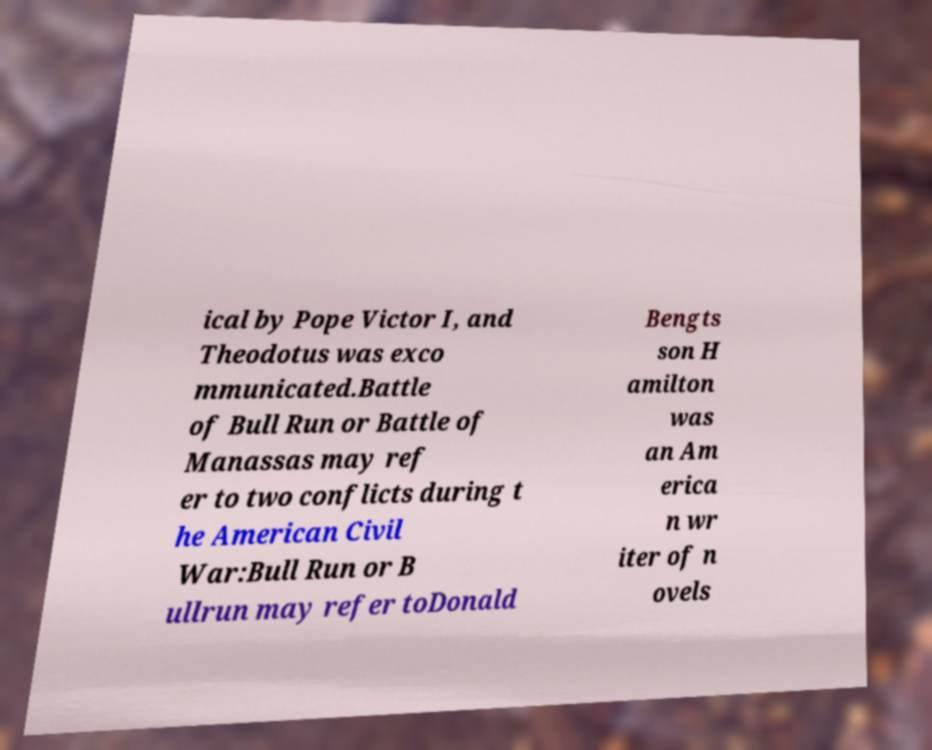Can you read and provide the text displayed in the image?This photo seems to have some interesting text. Can you extract and type it out for me? ical by Pope Victor I, and Theodotus was exco mmunicated.Battle of Bull Run or Battle of Manassas may ref er to two conflicts during t he American Civil War:Bull Run or B ullrun may refer toDonald Bengts son H amilton was an Am erica n wr iter of n ovels 